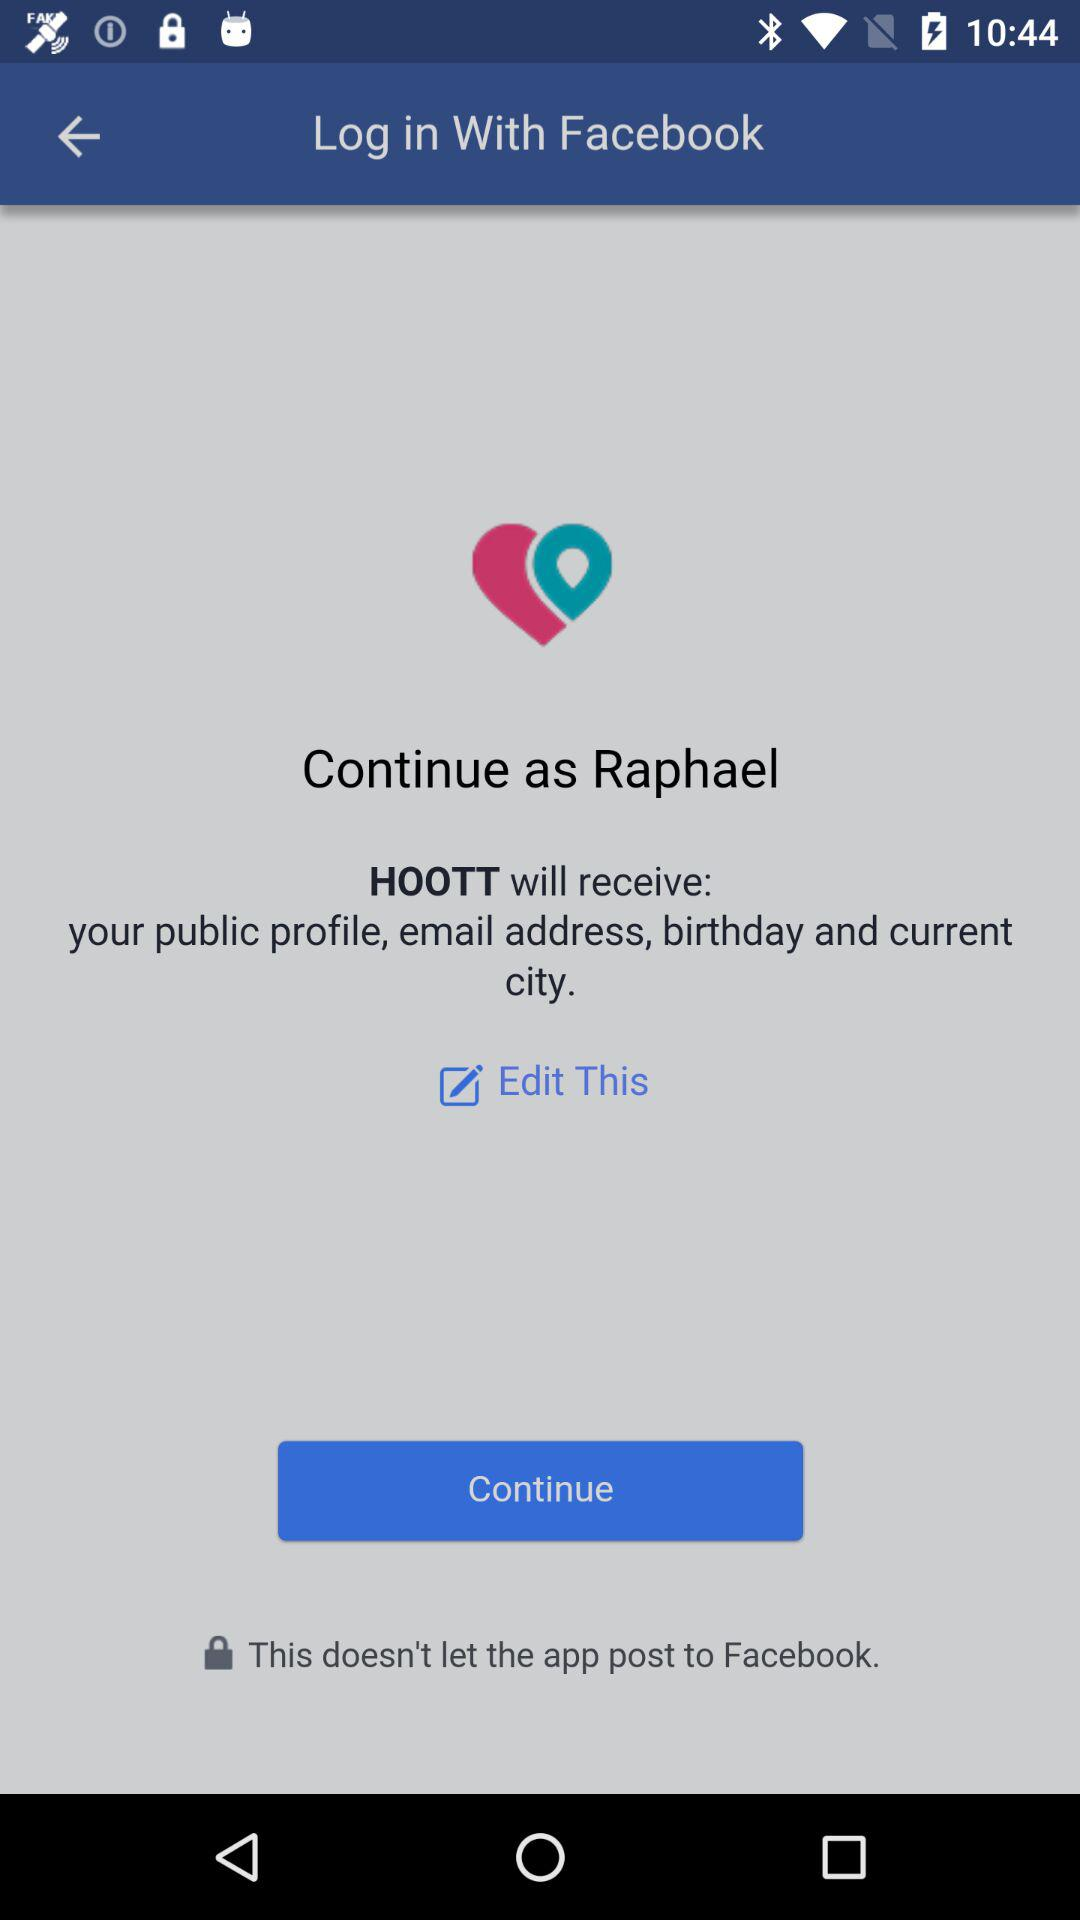What is login name? The login name is Raphael. 